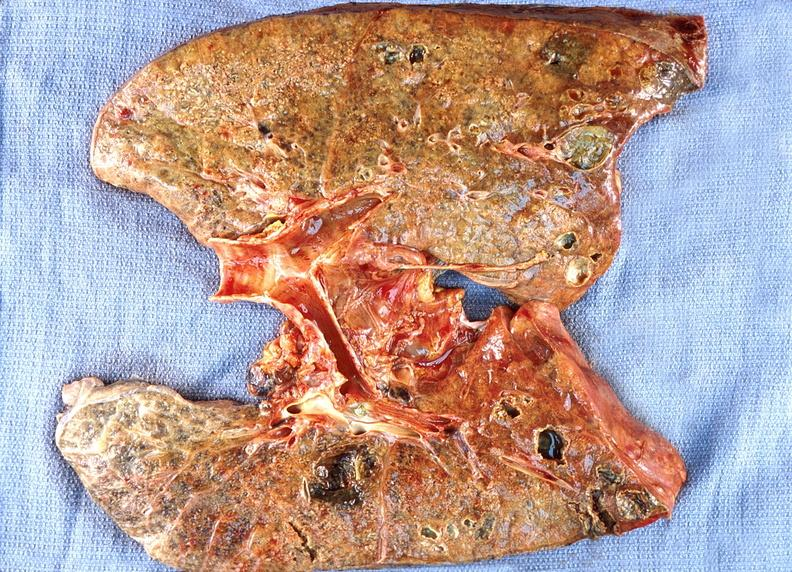does this image show lung abscess?
Answer the question using a single word or phrase. Yes 